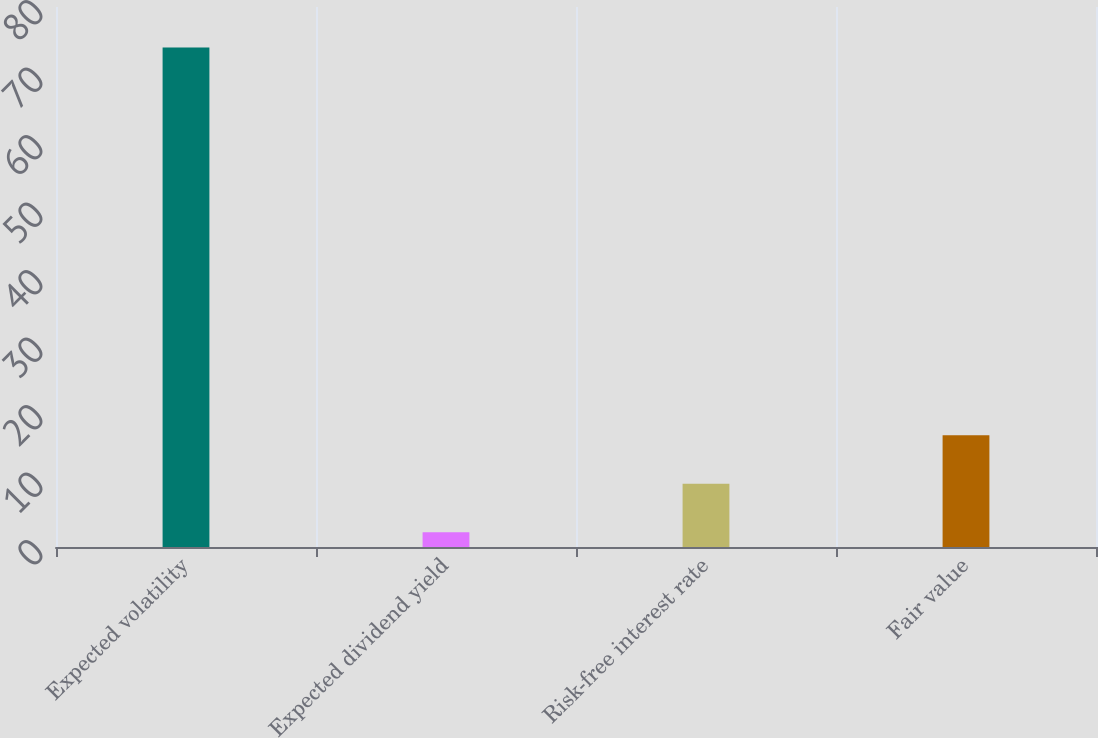Convert chart. <chart><loc_0><loc_0><loc_500><loc_500><bar_chart><fcel>Expected volatility<fcel>Expected dividend yield<fcel>Risk-free interest rate<fcel>Fair value<nl><fcel>74<fcel>2.2<fcel>9.38<fcel>16.56<nl></chart> 